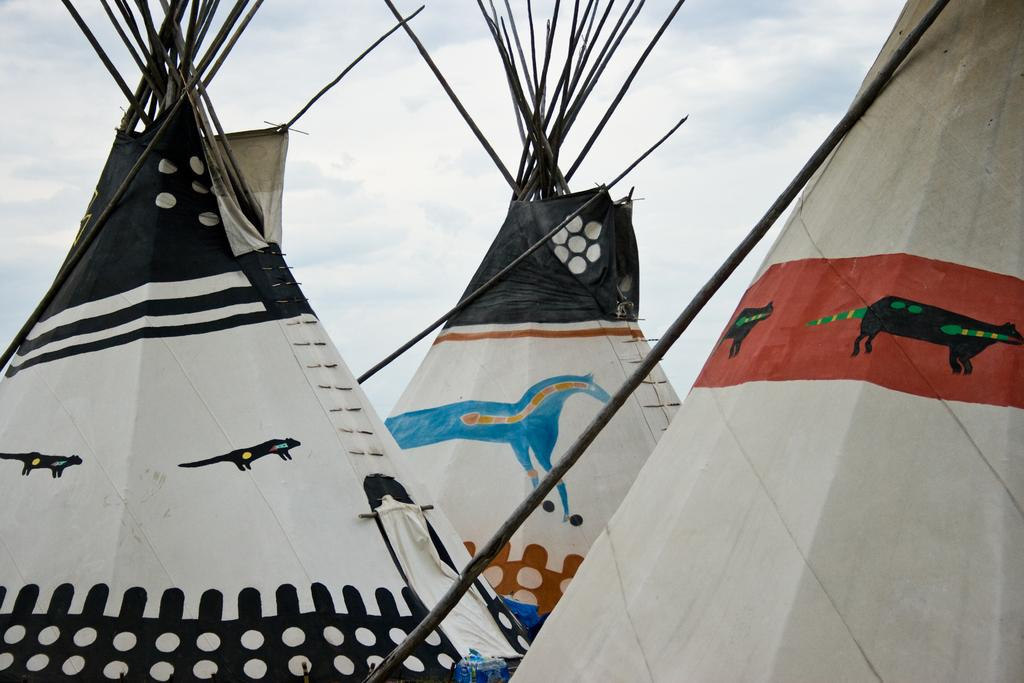What type of tents are in the image? There are three Tipi tents in the image. What can be seen in the background of the image? The sky is visible in the background of the image. What is the condition of the sky in the image? Clouds are present in the sky. What type of adjustment can be seen on the rabbit's ear in the image? There is no rabbit present in the image, so no adjustment can be seen on its ear. 